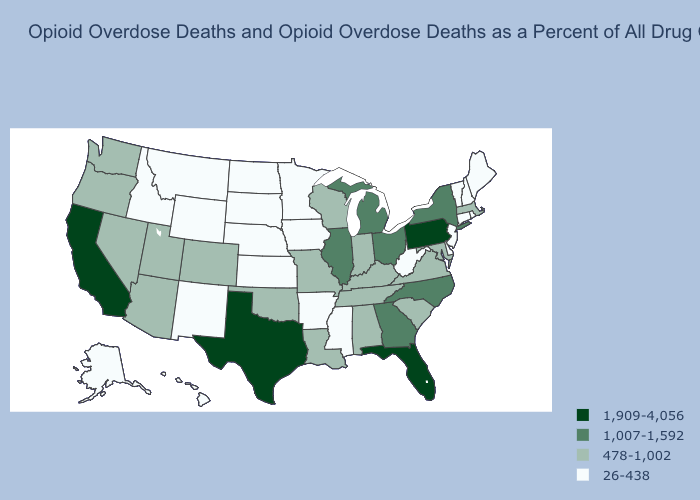Does the first symbol in the legend represent the smallest category?
Concise answer only. No. Among the states that border New Hampshire , does Massachusetts have the lowest value?
Quick response, please. No. Does Virginia have the lowest value in the South?
Concise answer only. No. What is the value of Vermont?
Concise answer only. 26-438. Does the first symbol in the legend represent the smallest category?
Quick response, please. No. Does Hawaii have the lowest value in the West?
Give a very brief answer. Yes. Name the states that have a value in the range 1,007-1,592?
Concise answer only. Georgia, Illinois, Michigan, New York, North Carolina, Ohio. Which states have the highest value in the USA?
Answer briefly. California, Florida, Pennsylvania, Texas. What is the value of Delaware?
Answer briefly. 26-438. Among the states that border Louisiana , does Texas have the highest value?
Write a very short answer. Yes. Name the states that have a value in the range 1,007-1,592?
Keep it brief. Georgia, Illinois, Michigan, New York, North Carolina, Ohio. Name the states that have a value in the range 478-1,002?
Short answer required. Alabama, Arizona, Colorado, Indiana, Kentucky, Louisiana, Maryland, Massachusetts, Missouri, Nevada, Oklahoma, Oregon, South Carolina, Tennessee, Utah, Virginia, Washington, Wisconsin. Among the states that border Nebraska , which have the highest value?
Quick response, please. Colorado, Missouri. Which states hav the highest value in the South?
Concise answer only. Florida, Texas. What is the value of Arkansas?
Be succinct. 26-438. 